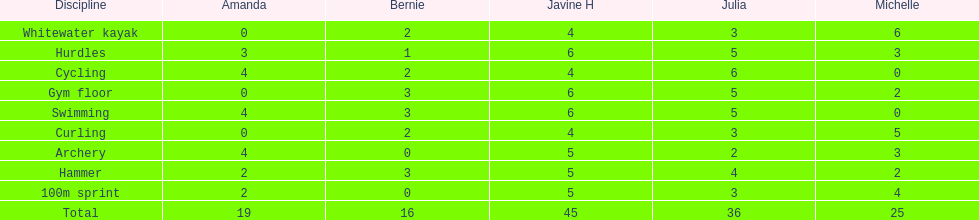What is the last discipline listed on this chart? 100m sprint. 